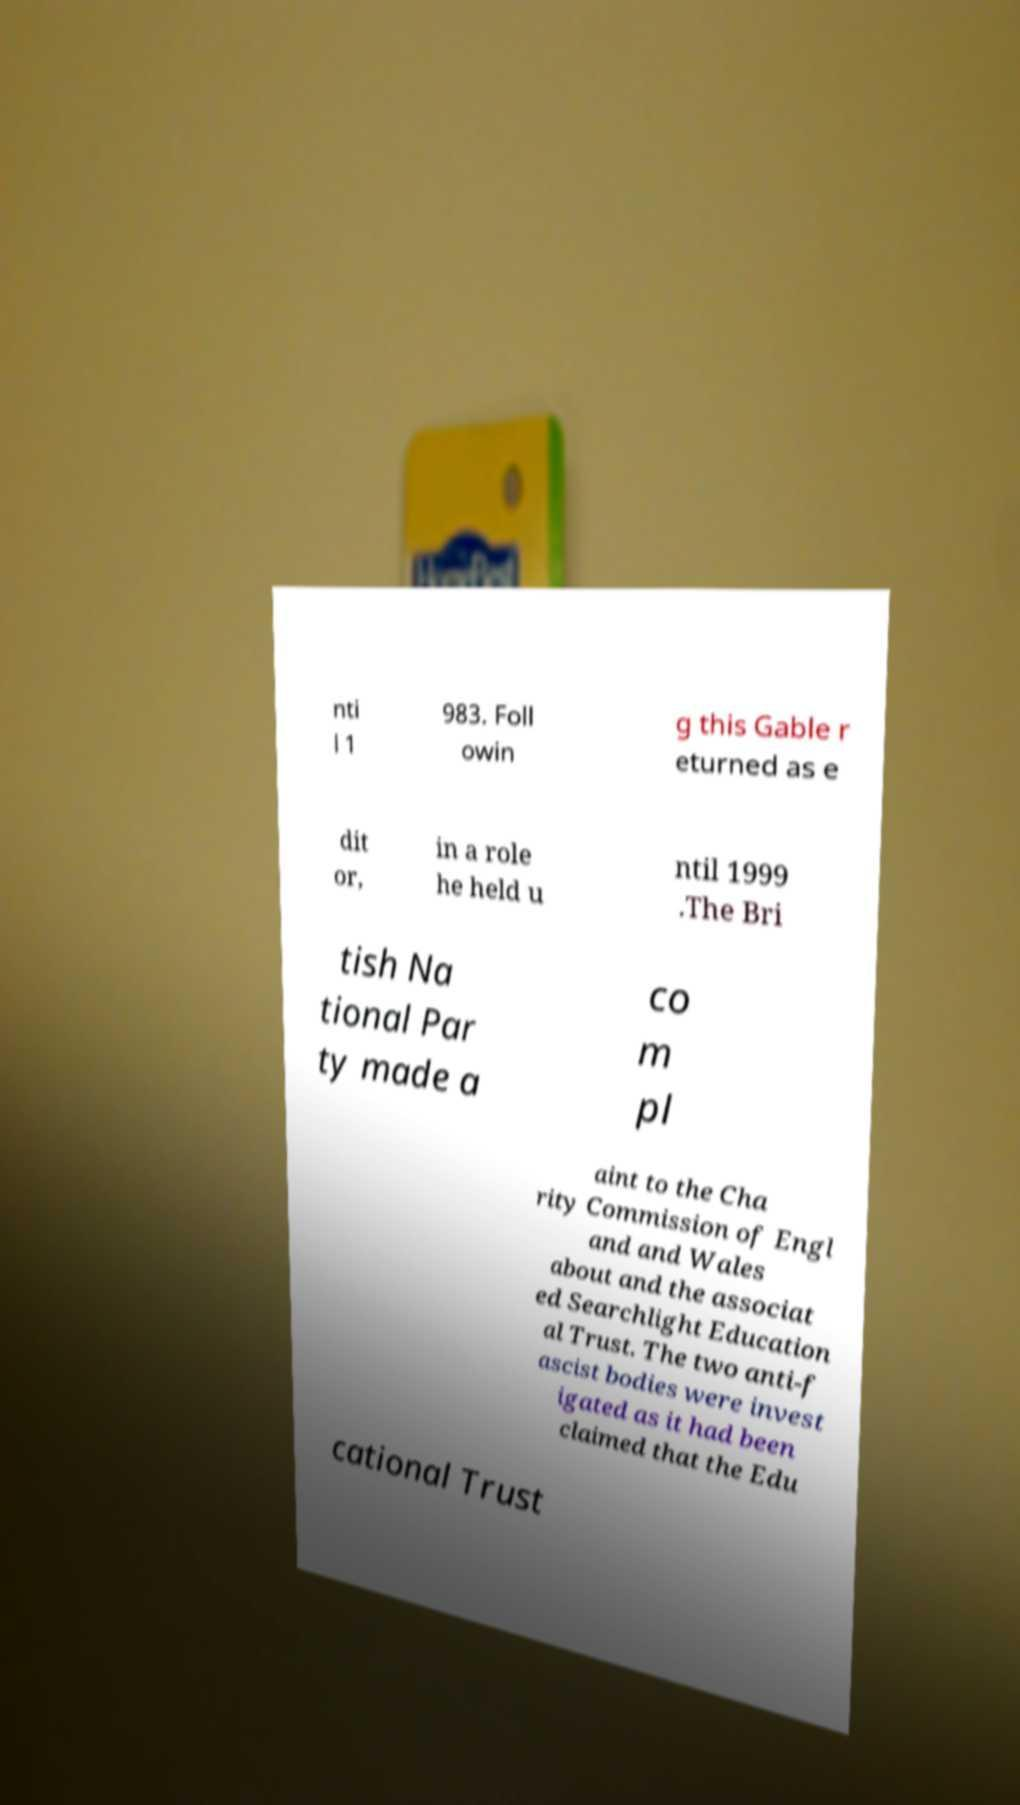Please read and relay the text visible in this image. What does it say? nti l 1 983. Foll owin g this Gable r eturned as e dit or, in a role he held u ntil 1999 .The Bri tish Na tional Par ty made a co m pl aint to the Cha rity Commission of Engl and and Wales about and the associat ed Searchlight Education al Trust. The two anti-f ascist bodies were invest igated as it had been claimed that the Edu cational Trust 